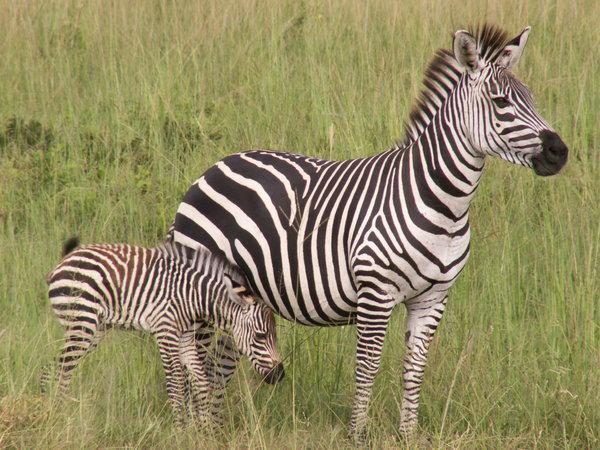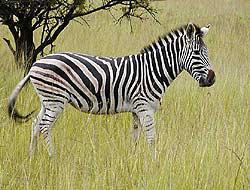The first image is the image on the left, the second image is the image on the right. Given the left and right images, does the statement "Three zebras are nicely lined up in both of the pictures." hold true? Answer yes or no. No. 